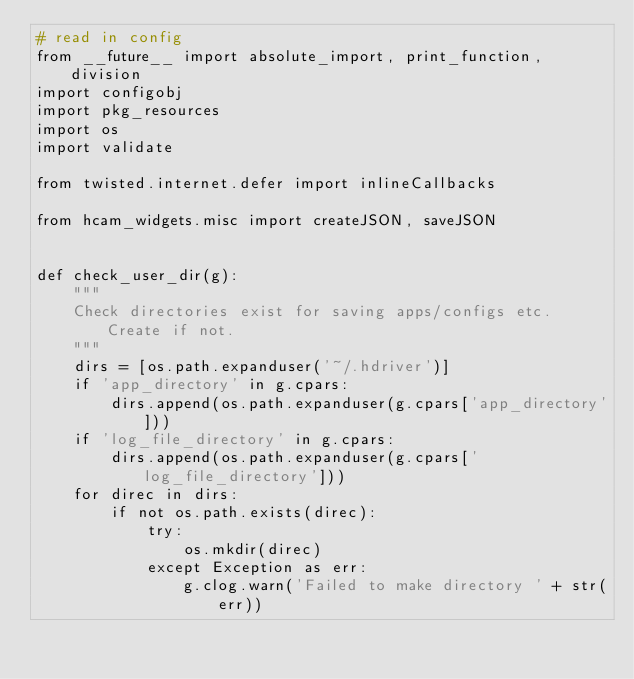Convert code to text. <code><loc_0><loc_0><loc_500><loc_500><_Python_># read in config
from __future__ import absolute_import, print_function, division
import configobj
import pkg_resources
import os
import validate

from twisted.internet.defer import inlineCallbacks

from hcam_widgets.misc import createJSON, saveJSON


def check_user_dir(g):
    """
    Check directories exist for saving apps/configs etc. Create if not.
    """
    dirs = [os.path.expanduser('~/.hdriver')]
    if 'app_directory' in g.cpars:
        dirs.append(os.path.expanduser(g.cpars['app_directory']))
    if 'log_file_directory' in g.cpars:
        dirs.append(os.path.expanduser(g.cpars['log_file_directory']))
    for direc in dirs:
        if not os.path.exists(direc):
            try:
                os.mkdir(direc)
            except Exception as err:
                g.clog.warn('Failed to make directory ' + str(err))

</code> 